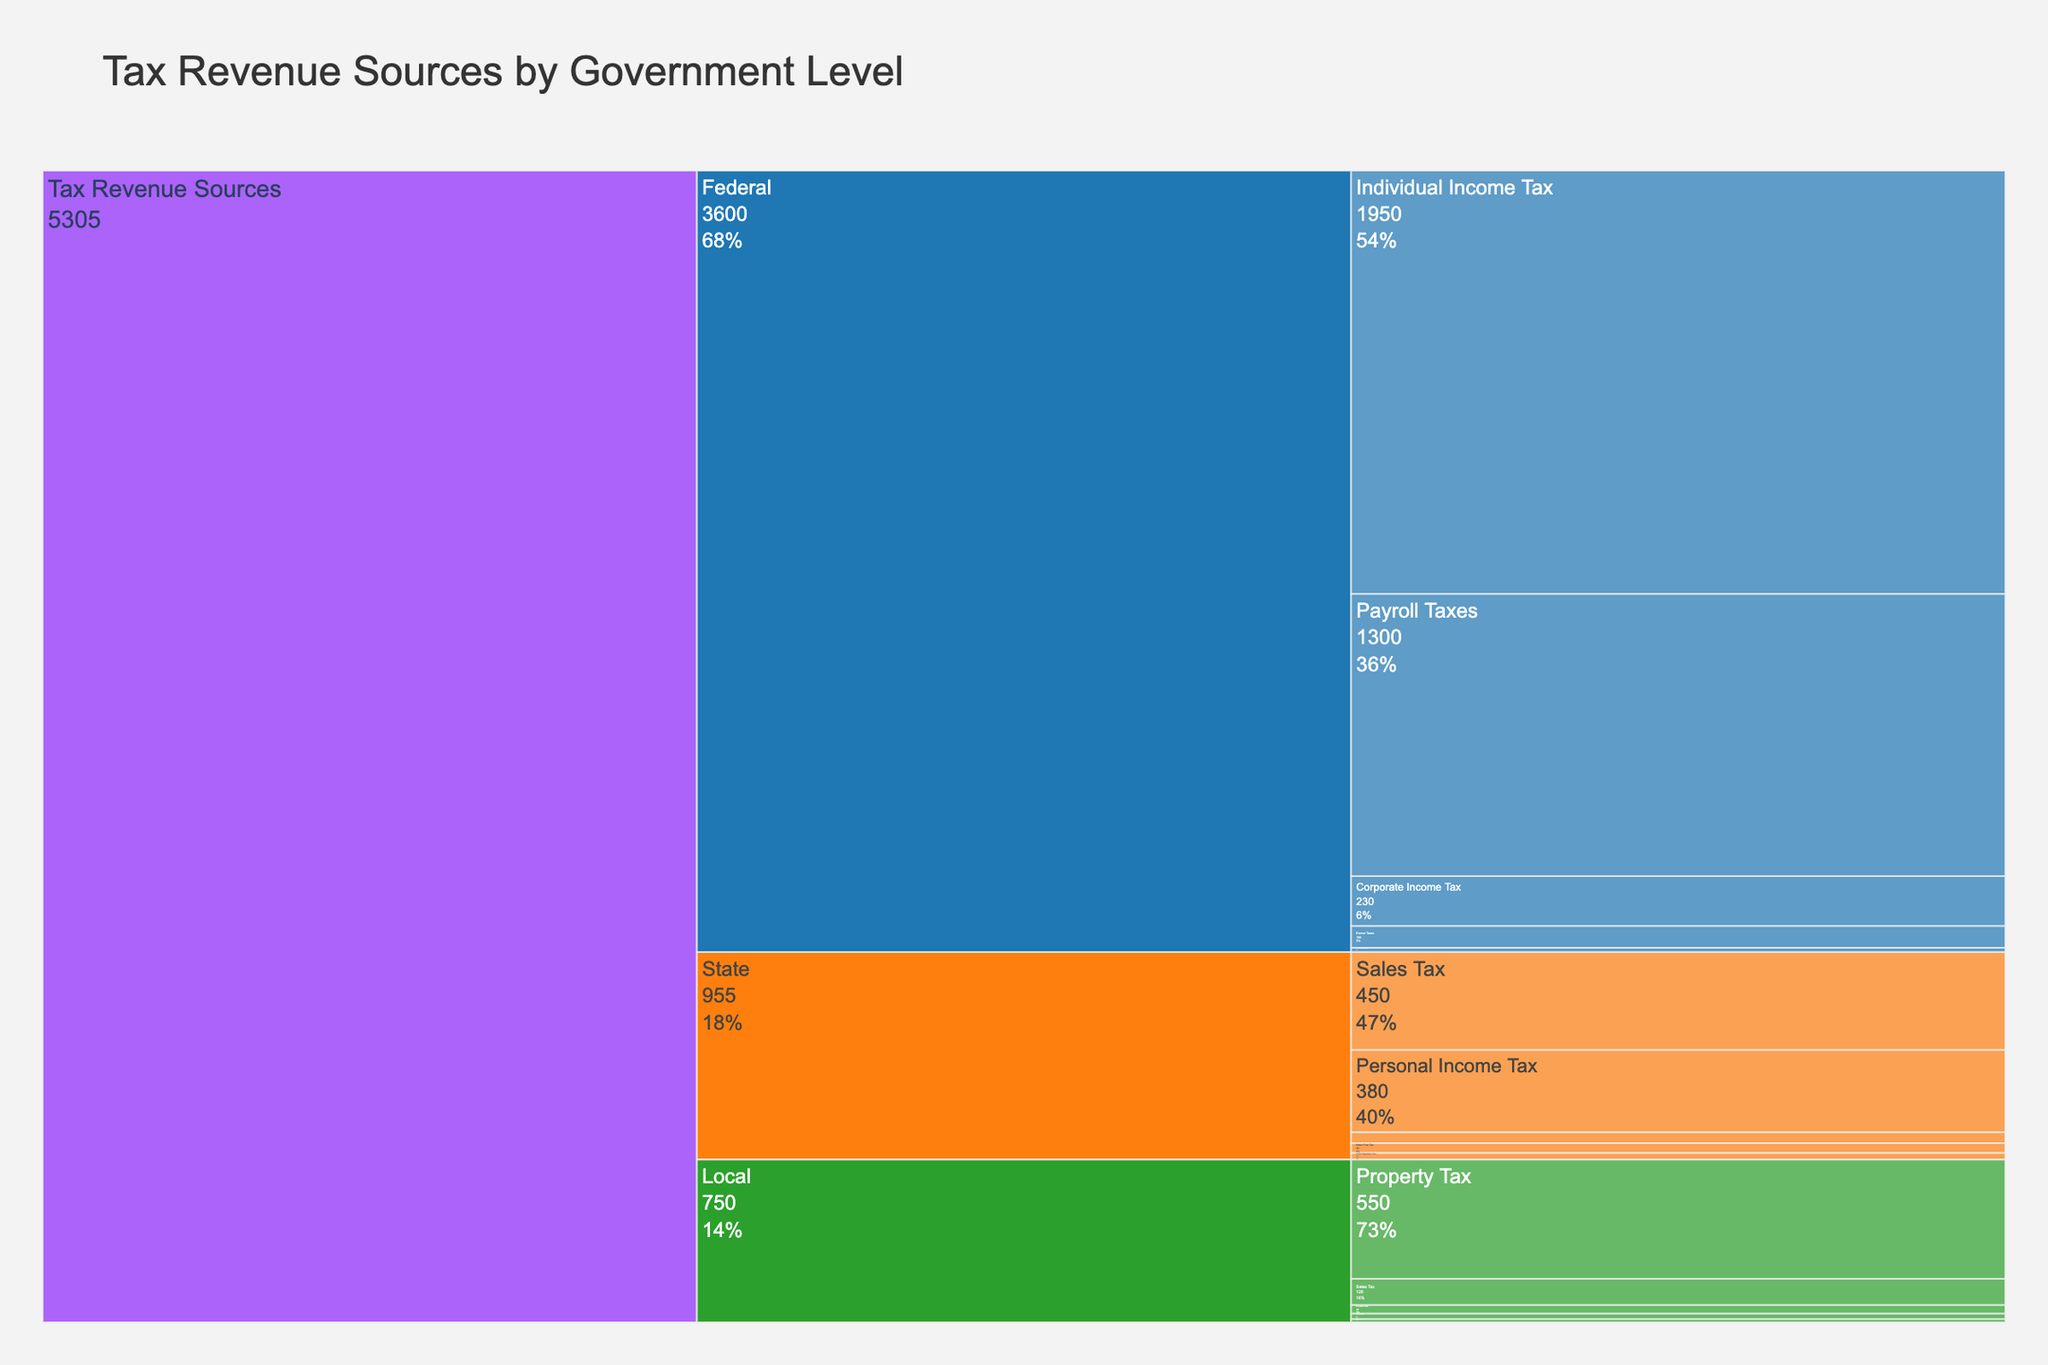what is the title of the figure? The title of the figure appears at the top and is usually the largest text. It gives an overview of what the figure represents. In this case, it states the main topic of the chart.
Answer: Tax Revenue Sources by Government Level Which Government Level has the highest overall tax revenue? By examining the icicle chart, you can see the relative sizes of the sections representing Federal, State, and Local tax revenues. The Federal section is the largest, indicating the highest tax revenue.
Answer: Federal What is the total revenue from Individual Income Tax at both Federal and State levels? Sum the value for Individual Income Tax under Federal and Personal Income Tax under State. Federal: $1950B, State: $380B. $1950B + $380B = $2330B.
Answer: $2330B How does the revenue from State Personal Income Tax compare to Local Property Tax? Compare the values given for each tax category. State Personal Income Tax is $380B, whereas Local Property Tax is $550B.
Answer: Local Property Tax is larger What percentage of Federal tax revenue comes from Payroll Taxes? First, calculate the total Federal tax revenue: $1950B + $230B + $1300B + $100B + $20B = $3600B. Then, find the percentage of Payroll Taxes: ($1300B / $3600B) * 100% = 36.1%.
Answer: 36.1% Adding which two State tax revenue sources will give you the closest total revenue to Local Property Tax? The goal is to find two State revenue sources that sum closest to $550B (Local Property Tax). State Sales Tax: $450B and State Motor Fuel Tax: $45B together total $495B, which is the closest.
Answer: Sales Tax and Motor Fuel Tax What is the total tax revenue for all government levels combined? Sum the values for all federal, state, and local tax revenue categories. Federal: $3600B, State: $955B, Local: $750B. $3600B + $955B + $750B = $5305B.
Answer: $5305B Which tax category under Federal government has the smallest revenue? Each Federal tax category is represented with its associated value. Estate and Gift Taxes have the smallest value at $20B.
Answer: Estate and Gift Taxes What is the difference in revenue between Federal Individual Income Tax and Local Sales Tax? Federal Individual Income Tax: $1950B, Local Sales Tax: $120B. Difference: $1950B - $120B = $1830B.
Answer: $1830B What is the combined tax revenue from Property Tax and Utility Taxes at the local level? Add values of local Property Tax ($550B) and Utility Taxes ($25B). $550B + $25B = $575B.
Answer: $575B 